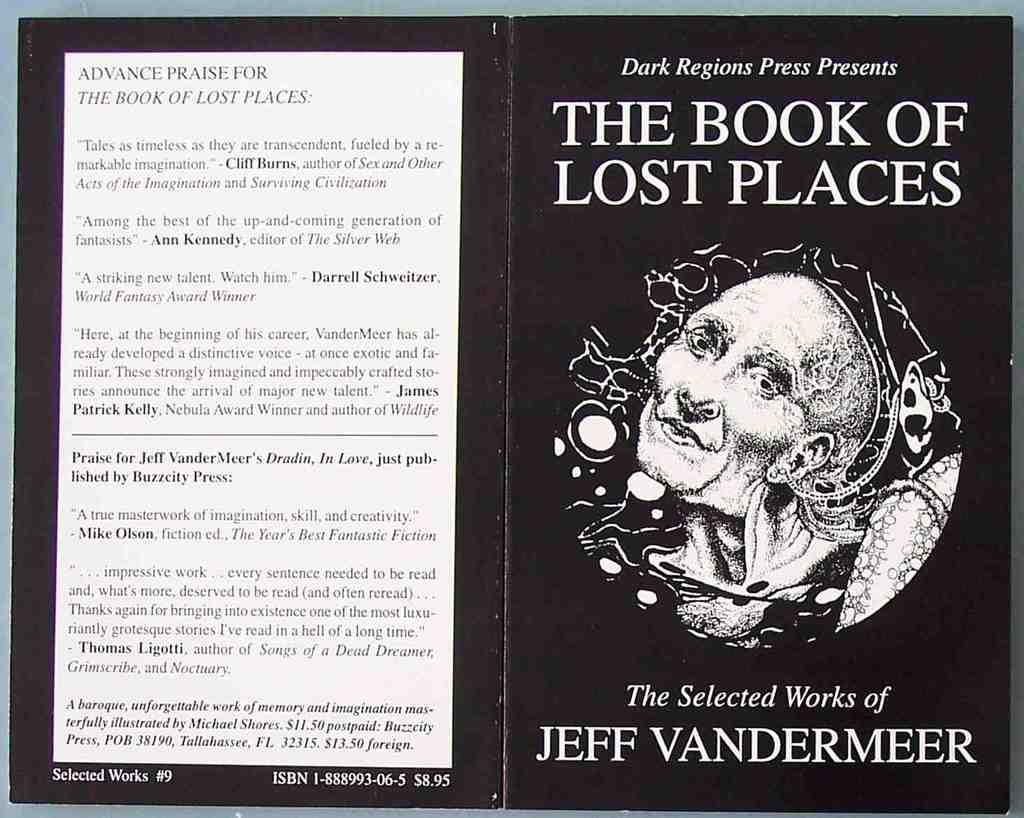<image>
Share a concise interpretation of the image provided. The book cover and back of the book of lost places 